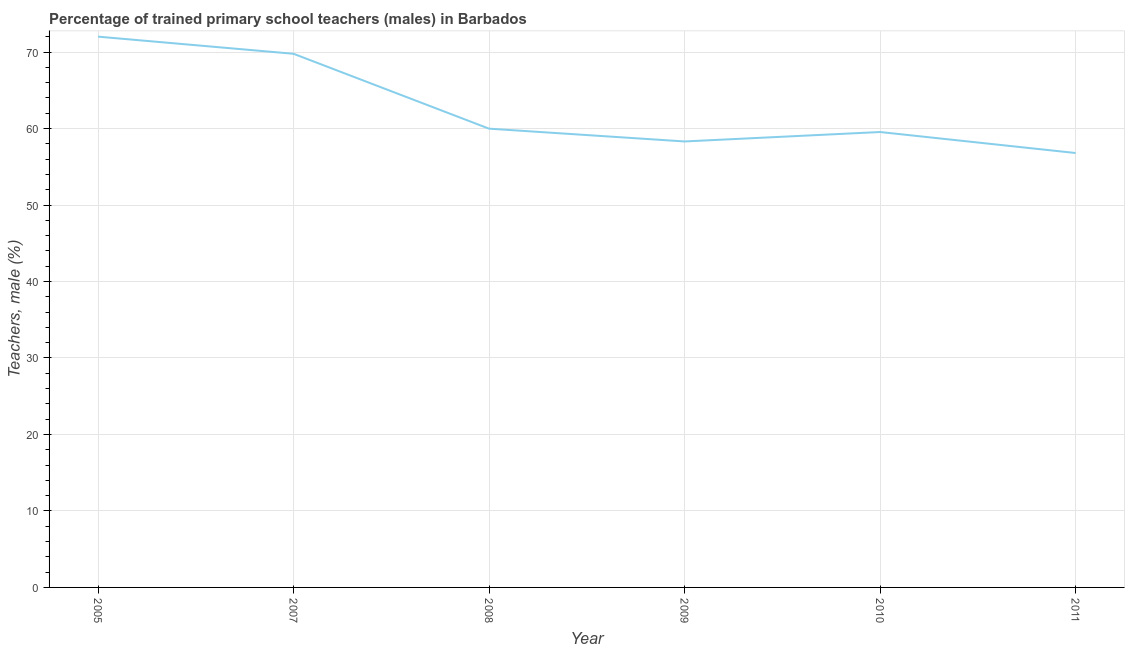What is the percentage of trained male teachers in 2010?
Give a very brief answer. 59.55. Across all years, what is the maximum percentage of trained male teachers?
Provide a short and direct response. 72.02. Across all years, what is the minimum percentage of trained male teachers?
Offer a terse response. 56.8. What is the sum of the percentage of trained male teachers?
Offer a terse response. 376.44. What is the difference between the percentage of trained male teachers in 2007 and 2008?
Offer a very short reply. 9.79. What is the average percentage of trained male teachers per year?
Offer a terse response. 62.74. What is the median percentage of trained male teachers?
Offer a terse response. 59.77. In how many years, is the percentage of trained male teachers greater than 32 %?
Ensure brevity in your answer.  6. Do a majority of the years between 2009 and 2011 (inclusive) have percentage of trained male teachers greater than 70 %?
Provide a succinct answer. No. What is the ratio of the percentage of trained male teachers in 2005 to that in 2007?
Provide a short and direct response. 1.03. What is the difference between the highest and the second highest percentage of trained male teachers?
Provide a succinct answer. 2.24. Is the sum of the percentage of trained male teachers in 2005 and 2010 greater than the maximum percentage of trained male teachers across all years?
Provide a succinct answer. Yes. What is the difference between the highest and the lowest percentage of trained male teachers?
Your answer should be compact. 15.22. In how many years, is the percentage of trained male teachers greater than the average percentage of trained male teachers taken over all years?
Provide a short and direct response. 2. Does the percentage of trained male teachers monotonically increase over the years?
Make the answer very short. No. How many lines are there?
Offer a terse response. 1. What is the difference between two consecutive major ticks on the Y-axis?
Provide a succinct answer. 10. Are the values on the major ticks of Y-axis written in scientific E-notation?
Your answer should be very brief. No. Does the graph contain any zero values?
Your answer should be compact. No. Does the graph contain grids?
Your answer should be compact. Yes. What is the title of the graph?
Make the answer very short. Percentage of trained primary school teachers (males) in Barbados. What is the label or title of the X-axis?
Provide a short and direct response. Year. What is the label or title of the Y-axis?
Keep it short and to the point. Teachers, male (%). What is the Teachers, male (%) of 2005?
Keep it short and to the point. 72.02. What is the Teachers, male (%) in 2007?
Your answer should be very brief. 69.78. What is the Teachers, male (%) of 2008?
Provide a short and direct response. 59.99. What is the Teachers, male (%) in 2009?
Keep it short and to the point. 58.31. What is the Teachers, male (%) of 2010?
Offer a very short reply. 59.55. What is the Teachers, male (%) in 2011?
Provide a succinct answer. 56.8. What is the difference between the Teachers, male (%) in 2005 and 2007?
Make the answer very short. 2.24. What is the difference between the Teachers, male (%) in 2005 and 2008?
Offer a very short reply. 12.03. What is the difference between the Teachers, male (%) in 2005 and 2009?
Your answer should be compact. 13.7. What is the difference between the Teachers, male (%) in 2005 and 2010?
Keep it short and to the point. 12.47. What is the difference between the Teachers, male (%) in 2005 and 2011?
Ensure brevity in your answer.  15.22. What is the difference between the Teachers, male (%) in 2007 and 2008?
Keep it short and to the point. 9.79. What is the difference between the Teachers, male (%) in 2007 and 2009?
Offer a very short reply. 11.46. What is the difference between the Teachers, male (%) in 2007 and 2010?
Make the answer very short. 10.23. What is the difference between the Teachers, male (%) in 2007 and 2011?
Keep it short and to the point. 12.98. What is the difference between the Teachers, male (%) in 2008 and 2009?
Make the answer very short. 1.67. What is the difference between the Teachers, male (%) in 2008 and 2010?
Ensure brevity in your answer.  0.44. What is the difference between the Teachers, male (%) in 2008 and 2011?
Offer a terse response. 3.18. What is the difference between the Teachers, male (%) in 2009 and 2010?
Provide a succinct answer. -1.23. What is the difference between the Teachers, male (%) in 2009 and 2011?
Offer a very short reply. 1.51. What is the difference between the Teachers, male (%) in 2010 and 2011?
Your answer should be compact. 2.75. What is the ratio of the Teachers, male (%) in 2005 to that in 2007?
Keep it short and to the point. 1.03. What is the ratio of the Teachers, male (%) in 2005 to that in 2008?
Keep it short and to the point. 1.2. What is the ratio of the Teachers, male (%) in 2005 to that in 2009?
Give a very brief answer. 1.24. What is the ratio of the Teachers, male (%) in 2005 to that in 2010?
Ensure brevity in your answer.  1.21. What is the ratio of the Teachers, male (%) in 2005 to that in 2011?
Keep it short and to the point. 1.27. What is the ratio of the Teachers, male (%) in 2007 to that in 2008?
Ensure brevity in your answer.  1.16. What is the ratio of the Teachers, male (%) in 2007 to that in 2009?
Offer a terse response. 1.2. What is the ratio of the Teachers, male (%) in 2007 to that in 2010?
Give a very brief answer. 1.17. What is the ratio of the Teachers, male (%) in 2007 to that in 2011?
Make the answer very short. 1.23. What is the ratio of the Teachers, male (%) in 2008 to that in 2010?
Ensure brevity in your answer.  1.01. What is the ratio of the Teachers, male (%) in 2008 to that in 2011?
Offer a terse response. 1.06. What is the ratio of the Teachers, male (%) in 2009 to that in 2011?
Your answer should be very brief. 1.03. What is the ratio of the Teachers, male (%) in 2010 to that in 2011?
Provide a short and direct response. 1.05. 